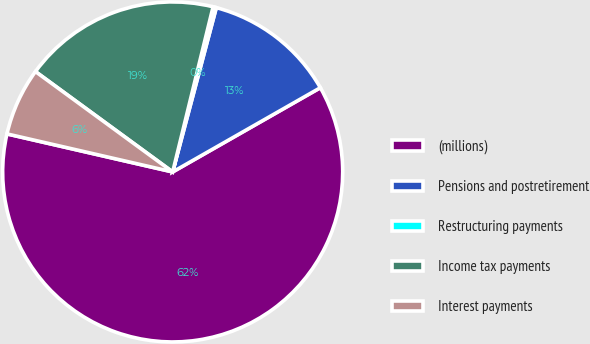<chart> <loc_0><loc_0><loc_500><loc_500><pie_chart><fcel>(millions)<fcel>Pensions and postretirement<fcel>Restructuring payments<fcel>Income tax payments<fcel>Interest payments<nl><fcel>61.84%<fcel>12.62%<fcel>0.31%<fcel>18.77%<fcel>6.46%<nl></chart> 